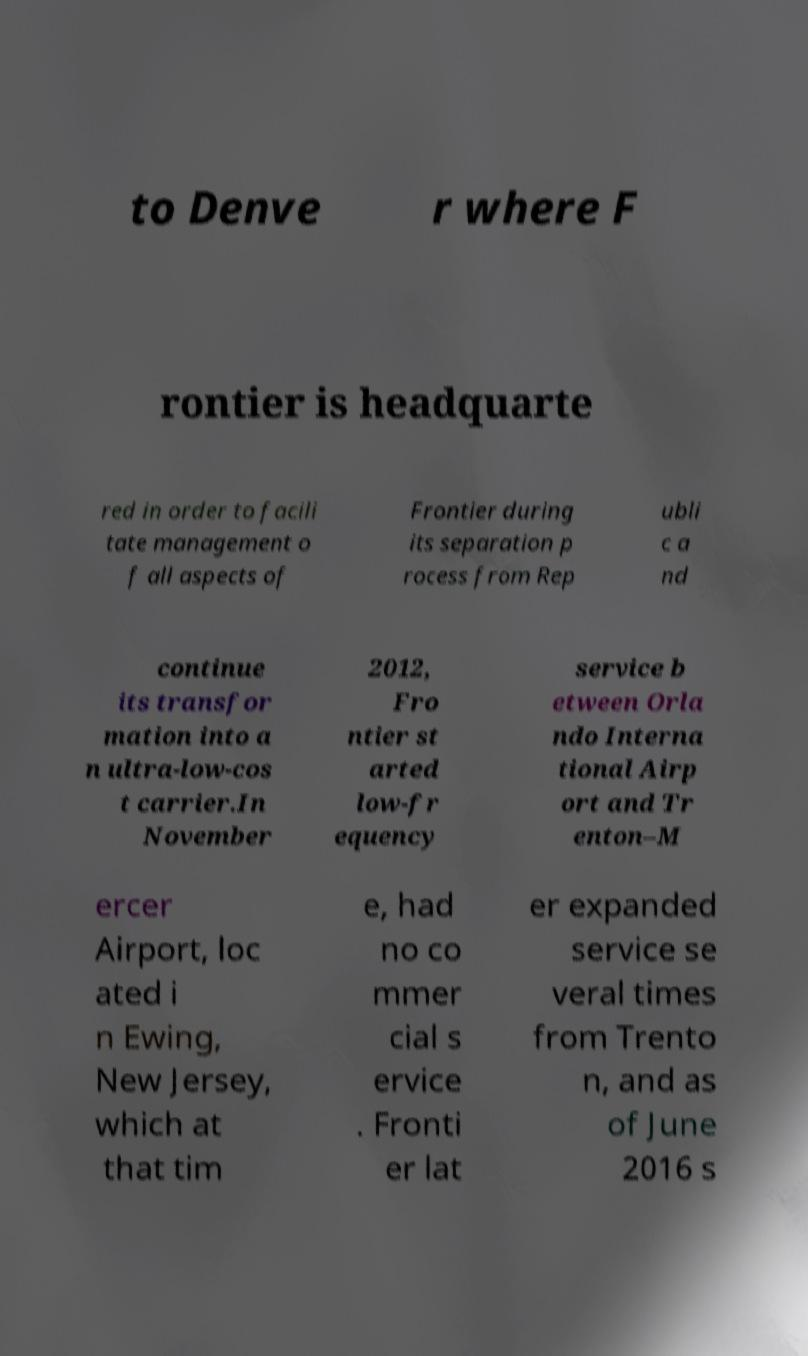Please identify and transcribe the text found in this image. to Denve r where F rontier is headquarte red in order to facili tate management o f all aspects of Frontier during its separation p rocess from Rep ubli c a nd continue its transfor mation into a n ultra-low-cos t carrier.In November 2012, Fro ntier st arted low-fr equency service b etween Orla ndo Interna tional Airp ort and Tr enton–M ercer Airport, loc ated i n Ewing, New Jersey, which at that tim e, had no co mmer cial s ervice . Fronti er lat er expanded service se veral times from Trento n, and as of June 2016 s 